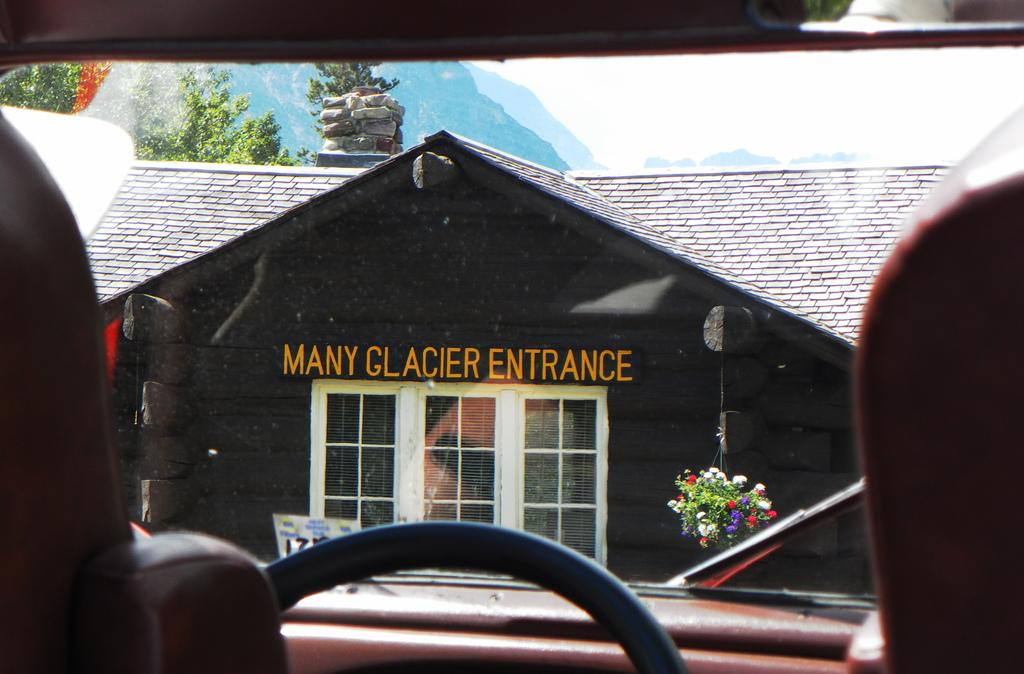What type of setting is depicted in the image? The image shows the interior view of a vehicle. What can be seen outside the vehicle in the image? There is a house with some text, plants with flowers, trees, hills, and the sky visible in the image. What type of canvas is being used to create the hills in the image? There is no canvas present in the image; the hills are a natural part of the landscape. What type of furniture can be seen inside the vehicle in the image? The image does not show the interior of the vehicle in enough detail to identify any specific furniture. 